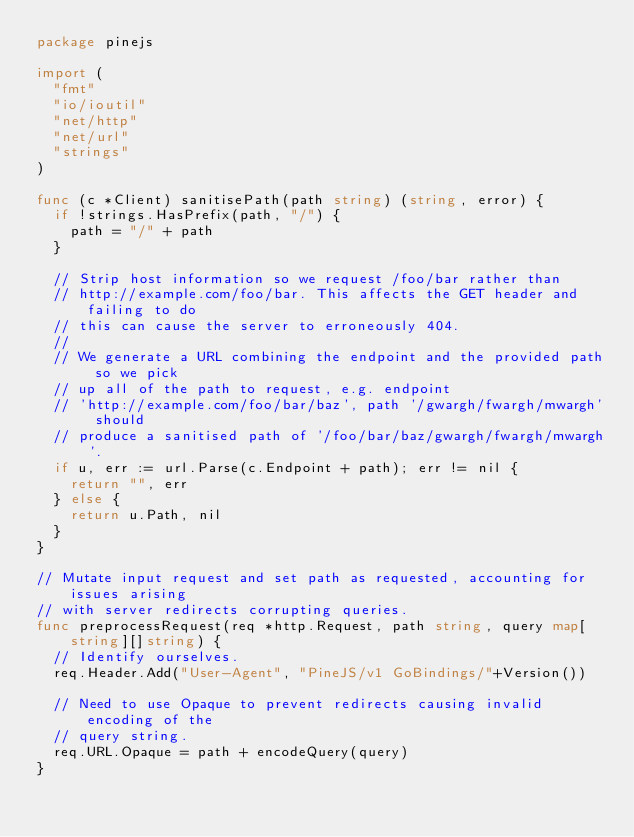Convert code to text. <code><loc_0><loc_0><loc_500><loc_500><_Go_>package pinejs

import (
	"fmt"
	"io/ioutil"
	"net/http"
	"net/url"
	"strings"
)

func (c *Client) sanitisePath(path string) (string, error) {
	if !strings.HasPrefix(path, "/") {
		path = "/" + path
	}

	// Strip host information so we request /foo/bar rather than
	// http://example.com/foo/bar. This affects the GET header and failing to do
	// this can cause the server to erroneously 404.
	//
	// We generate a URL combining the endpoint and the provided path so we pick
	// up all of the path to request, e.g. endpoint
	// 'http://example.com/foo/bar/baz', path '/gwargh/fwargh/mwargh' should
	// produce a sanitised path of '/foo/bar/baz/gwargh/fwargh/mwargh'.
	if u, err := url.Parse(c.Endpoint + path); err != nil {
		return "", err
	} else {
		return u.Path, nil
	}
}

// Mutate input request and set path as requested, accounting for issues arising
// with server redirects corrupting queries.
func preprocessRequest(req *http.Request, path string, query map[string][]string) {
	// Identify ourselves.
	req.Header.Add("User-Agent", "PineJS/v1 GoBindings/"+Version())

	// Need to use Opaque to prevent redirects causing invalid encoding of the
	// query string.
	req.URL.Opaque = path + encodeQuery(query)
}
</code> 